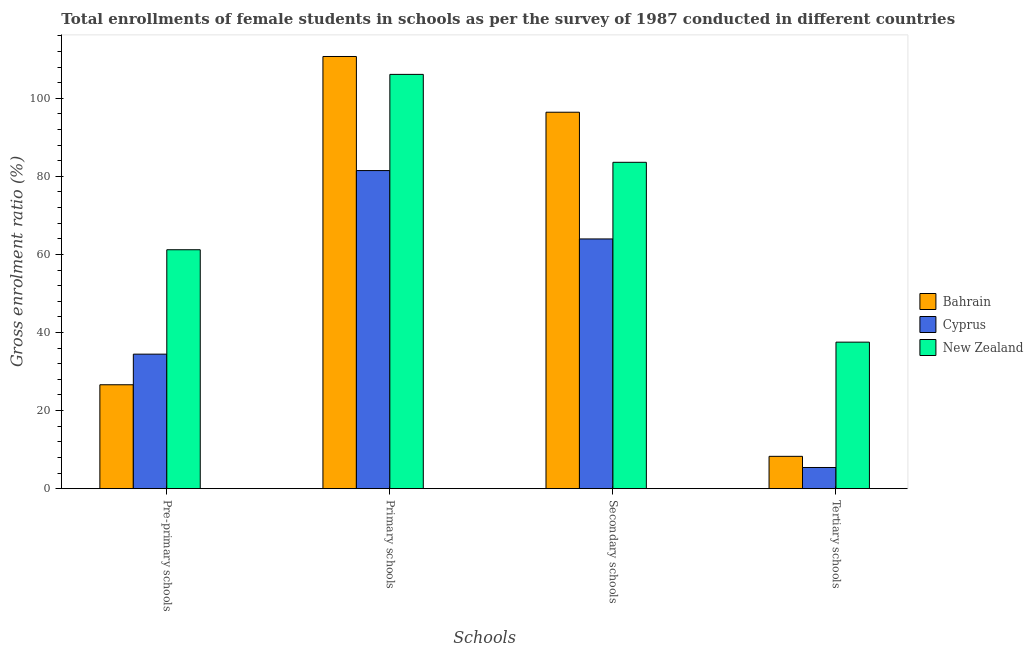How many different coloured bars are there?
Provide a succinct answer. 3. How many groups of bars are there?
Ensure brevity in your answer.  4. Are the number of bars on each tick of the X-axis equal?
Ensure brevity in your answer.  Yes. How many bars are there on the 4th tick from the left?
Your answer should be very brief. 3. How many bars are there on the 2nd tick from the right?
Offer a very short reply. 3. What is the label of the 1st group of bars from the left?
Provide a succinct answer. Pre-primary schools. What is the gross enrolment ratio(female) in primary schools in New Zealand?
Provide a succinct answer. 106.12. Across all countries, what is the maximum gross enrolment ratio(female) in pre-primary schools?
Ensure brevity in your answer.  61.2. Across all countries, what is the minimum gross enrolment ratio(female) in tertiary schools?
Keep it short and to the point. 5.43. In which country was the gross enrolment ratio(female) in pre-primary schools maximum?
Offer a very short reply. New Zealand. In which country was the gross enrolment ratio(female) in primary schools minimum?
Provide a short and direct response. Cyprus. What is the total gross enrolment ratio(female) in tertiary schools in the graph?
Offer a terse response. 51.24. What is the difference between the gross enrolment ratio(female) in tertiary schools in Bahrain and that in Cyprus?
Your answer should be very brief. 2.86. What is the difference between the gross enrolment ratio(female) in tertiary schools in New Zealand and the gross enrolment ratio(female) in primary schools in Bahrain?
Make the answer very short. -73.17. What is the average gross enrolment ratio(female) in pre-primary schools per country?
Ensure brevity in your answer.  40.76. What is the difference between the gross enrolment ratio(female) in secondary schools and gross enrolment ratio(female) in primary schools in Bahrain?
Your answer should be compact. -14.28. In how many countries, is the gross enrolment ratio(female) in primary schools greater than 84 %?
Offer a terse response. 2. What is the ratio of the gross enrolment ratio(female) in primary schools in New Zealand to that in Bahrain?
Offer a very short reply. 0.96. Is the gross enrolment ratio(female) in pre-primary schools in Cyprus less than that in New Zealand?
Provide a short and direct response. Yes. Is the difference between the gross enrolment ratio(female) in primary schools in Cyprus and Bahrain greater than the difference between the gross enrolment ratio(female) in tertiary schools in Cyprus and Bahrain?
Offer a very short reply. No. What is the difference between the highest and the second highest gross enrolment ratio(female) in primary schools?
Give a very brief answer. 4.58. What is the difference between the highest and the lowest gross enrolment ratio(female) in tertiary schools?
Your response must be concise. 32.1. In how many countries, is the gross enrolment ratio(female) in pre-primary schools greater than the average gross enrolment ratio(female) in pre-primary schools taken over all countries?
Your answer should be compact. 1. What does the 3rd bar from the left in Tertiary schools represents?
Keep it short and to the point. New Zealand. What does the 2nd bar from the right in Tertiary schools represents?
Give a very brief answer. Cyprus. Does the graph contain any zero values?
Ensure brevity in your answer.  No. Where does the legend appear in the graph?
Provide a succinct answer. Center right. What is the title of the graph?
Offer a terse response. Total enrollments of female students in schools as per the survey of 1987 conducted in different countries. Does "Sub-Saharan Africa (developing only)" appear as one of the legend labels in the graph?
Make the answer very short. No. What is the label or title of the X-axis?
Provide a succinct answer. Schools. What is the label or title of the Y-axis?
Offer a very short reply. Gross enrolment ratio (%). What is the Gross enrolment ratio (%) in Bahrain in Pre-primary schools?
Your answer should be compact. 26.62. What is the Gross enrolment ratio (%) of Cyprus in Pre-primary schools?
Your answer should be compact. 34.46. What is the Gross enrolment ratio (%) of New Zealand in Pre-primary schools?
Offer a terse response. 61.2. What is the Gross enrolment ratio (%) of Bahrain in Primary schools?
Your answer should be very brief. 110.7. What is the Gross enrolment ratio (%) of Cyprus in Primary schools?
Make the answer very short. 81.48. What is the Gross enrolment ratio (%) in New Zealand in Primary schools?
Provide a short and direct response. 106.12. What is the Gross enrolment ratio (%) in Bahrain in Secondary schools?
Offer a terse response. 96.43. What is the Gross enrolment ratio (%) in Cyprus in Secondary schools?
Provide a short and direct response. 63.97. What is the Gross enrolment ratio (%) in New Zealand in Secondary schools?
Provide a succinct answer. 83.6. What is the Gross enrolment ratio (%) in Bahrain in Tertiary schools?
Provide a succinct answer. 8.28. What is the Gross enrolment ratio (%) of Cyprus in Tertiary schools?
Your answer should be very brief. 5.43. What is the Gross enrolment ratio (%) in New Zealand in Tertiary schools?
Provide a succinct answer. 37.53. Across all Schools, what is the maximum Gross enrolment ratio (%) of Bahrain?
Ensure brevity in your answer.  110.7. Across all Schools, what is the maximum Gross enrolment ratio (%) of Cyprus?
Provide a short and direct response. 81.48. Across all Schools, what is the maximum Gross enrolment ratio (%) of New Zealand?
Your answer should be compact. 106.12. Across all Schools, what is the minimum Gross enrolment ratio (%) in Bahrain?
Keep it short and to the point. 8.28. Across all Schools, what is the minimum Gross enrolment ratio (%) in Cyprus?
Ensure brevity in your answer.  5.43. Across all Schools, what is the minimum Gross enrolment ratio (%) in New Zealand?
Give a very brief answer. 37.53. What is the total Gross enrolment ratio (%) of Bahrain in the graph?
Your answer should be very brief. 242.03. What is the total Gross enrolment ratio (%) of Cyprus in the graph?
Ensure brevity in your answer.  185.33. What is the total Gross enrolment ratio (%) of New Zealand in the graph?
Offer a very short reply. 288.45. What is the difference between the Gross enrolment ratio (%) of Bahrain in Pre-primary schools and that in Primary schools?
Your response must be concise. -84.09. What is the difference between the Gross enrolment ratio (%) of Cyprus in Pre-primary schools and that in Primary schools?
Offer a terse response. -47.02. What is the difference between the Gross enrolment ratio (%) in New Zealand in Pre-primary schools and that in Primary schools?
Ensure brevity in your answer.  -44.92. What is the difference between the Gross enrolment ratio (%) in Bahrain in Pre-primary schools and that in Secondary schools?
Offer a very short reply. -69.81. What is the difference between the Gross enrolment ratio (%) of Cyprus in Pre-primary schools and that in Secondary schools?
Your answer should be very brief. -29.51. What is the difference between the Gross enrolment ratio (%) in New Zealand in Pre-primary schools and that in Secondary schools?
Your response must be concise. -22.4. What is the difference between the Gross enrolment ratio (%) in Bahrain in Pre-primary schools and that in Tertiary schools?
Keep it short and to the point. 18.33. What is the difference between the Gross enrolment ratio (%) of Cyprus in Pre-primary schools and that in Tertiary schools?
Provide a short and direct response. 29.03. What is the difference between the Gross enrolment ratio (%) in New Zealand in Pre-primary schools and that in Tertiary schools?
Your answer should be very brief. 23.67. What is the difference between the Gross enrolment ratio (%) of Bahrain in Primary schools and that in Secondary schools?
Give a very brief answer. 14.28. What is the difference between the Gross enrolment ratio (%) of Cyprus in Primary schools and that in Secondary schools?
Keep it short and to the point. 17.51. What is the difference between the Gross enrolment ratio (%) in New Zealand in Primary schools and that in Secondary schools?
Your response must be concise. 22.52. What is the difference between the Gross enrolment ratio (%) of Bahrain in Primary schools and that in Tertiary schools?
Make the answer very short. 102.42. What is the difference between the Gross enrolment ratio (%) of Cyprus in Primary schools and that in Tertiary schools?
Offer a terse response. 76.05. What is the difference between the Gross enrolment ratio (%) of New Zealand in Primary schools and that in Tertiary schools?
Ensure brevity in your answer.  68.59. What is the difference between the Gross enrolment ratio (%) of Bahrain in Secondary schools and that in Tertiary schools?
Offer a terse response. 88.14. What is the difference between the Gross enrolment ratio (%) in Cyprus in Secondary schools and that in Tertiary schools?
Provide a succinct answer. 58.54. What is the difference between the Gross enrolment ratio (%) in New Zealand in Secondary schools and that in Tertiary schools?
Offer a terse response. 46.07. What is the difference between the Gross enrolment ratio (%) of Bahrain in Pre-primary schools and the Gross enrolment ratio (%) of Cyprus in Primary schools?
Your answer should be very brief. -54.86. What is the difference between the Gross enrolment ratio (%) in Bahrain in Pre-primary schools and the Gross enrolment ratio (%) in New Zealand in Primary schools?
Provide a succinct answer. -79.5. What is the difference between the Gross enrolment ratio (%) of Cyprus in Pre-primary schools and the Gross enrolment ratio (%) of New Zealand in Primary schools?
Your answer should be compact. -71.66. What is the difference between the Gross enrolment ratio (%) of Bahrain in Pre-primary schools and the Gross enrolment ratio (%) of Cyprus in Secondary schools?
Offer a very short reply. -37.35. What is the difference between the Gross enrolment ratio (%) in Bahrain in Pre-primary schools and the Gross enrolment ratio (%) in New Zealand in Secondary schools?
Your response must be concise. -56.98. What is the difference between the Gross enrolment ratio (%) in Cyprus in Pre-primary schools and the Gross enrolment ratio (%) in New Zealand in Secondary schools?
Provide a short and direct response. -49.14. What is the difference between the Gross enrolment ratio (%) of Bahrain in Pre-primary schools and the Gross enrolment ratio (%) of Cyprus in Tertiary schools?
Offer a terse response. 21.19. What is the difference between the Gross enrolment ratio (%) of Bahrain in Pre-primary schools and the Gross enrolment ratio (%) of New Zealand in Tertiary schools?
Provide a succinct answer. -10.92. What is the difference between the Gross enrolment ratio (%) of Cyprus in Pre-primary schools and the Gross enrolment ratio (%) of New Zealand in Tertiary schools?
Make the answer very short. -3.07. What is the difference between the Gross enrolment ratio (%) in Bahrain in Primary schools and the Gross enrolment ratio (%) in Cyprus in Secondary schools?
Your answer should be very brief. 46.74. What is the difference between the Gross enrolment ratio (%) of Bahrain in Primary schools and the Gross enrolment ratio (%) of New Zealand in Secondary schools?
Provide a succinct answer. 27.11. What is the difference between the Gross enrolment ratio (%) in Cyprus in Primary schools and the Gross enrolment ratio (%) in New Zealand in Secondary schools?
Make the answer very short. -2.12. What is the difference between the Gross enrolment ratio (%) of Bahrain in Primary schools and the Gross enrolment ratio (%) of Cyprus in Tertiary schools?
Make the answer very short. 105.28. What is the difference between the Gross enrolment ratio (%) of Bahrain in Primary schools and the Gross enrolment ratio (%) of New Zealand in Tertiary schools?
Keep it short and to the point. 73.17. What is the difference between the Gross enrolment ratio (%) of Cyprus in Primary schools and the Gross enrolment ratio (%) of New Zealand in Tertiary schools?
Your answer should be compact. 43.95. What is the difference between the Gross enrolment ratio (%) of Bahrain in Secondary schools and the Gross enrolment ratio (%) of Cyprus in Tertiary schools?
Give a very brief answer. 91. What is the difference between the Gross enrolment ratio (%) in Bahrain in Secondary schools and the Gross enrolment ratio (%) in New Zealand in Tertiary schools?
Provide a short and direct response. 58.89. What is the difference between the Gross enrolment ratio (%) of Cyprus in Secondary schools and the Gross enrolment ratio (%) of New Zealand in Tertiary schools?
Give a very brief answer. 26.44. What is the average Gross enrolment ratio (%) of Bahrain per Schools?
Offer a very short reply. 60.51. What is the average Gross enrolment ratio (%) of Cyprus per Schools?
Make the answer very short. 46.33. What is the average Gross enrolment ratio (%) in New Zealand per Schools?
Make the answer very short. 72.11. What is the difference between the Gross enrolment ratio (%) of Bahrain and Gross enrolment ratio (%) of Cyprus in Pre-primary schools?
Ensure brevity in your answer.  -7.84. What is the difference between the Gross enrolment ratio (%) of Bahrain and Gross enrolment ratio (%) of New Zealand in Pre-primary schools?
Ensure brevity in your answer.  -34.59. What is the difference between the Gross enrolment ratio (%) of Cyprus and Gross enrolment ratio (%) of New Zealand in Pre-primary schools?
Keep it short and to the point. -26.74. What is the difference between the Gross enrolment ratio (%) in Bahrain and Gross enrolment ratio (%) in Cyprus in Primary schools?
Keep it short and to the point. 29.22. What is the difference between the Gross enrolment ratio (%) in Bahrain and Gross enrolment ratio (%) in New Zealand in Primary schools?
Your response must be concise. 4.58. What is the difference between the Gross enrolment ratio (%) in Cyprus and Gross enrolment ratio (%) in New Zealand in Primary schools?
Your answer should be very brief. -24.64. What is the difference between the Gross enrolment ratio (%) of Bahrain and Gross enrolment ratio (%) of Cyprus in Secondary schools?
Offer a very short reply. 32.46. What is the difference between the Gross enrolment ratio (%) in Bahrain and Gross enrolment ratio (%) in New Zealand in Secondary schools?
Your answer should be very brief. 12.83. What is the difference between the Gross enrolment ratio (%) in Cyprus and Gross enrolment ratio (%) in New Zealand in Secondary schools?
Ensure brevity in your answer.  -19.63. What is the difference between the Gross enrolment ratio (%) of Bahrain and Gross enrolment ratio (%) of Cyprus in Tertiary schools?
Make the answer very short. 2.86. What is the difference between the Gross enrolment ratio (%) in Bahrain and Gross enrolment ratio (%) in New Zealand in Tertiary schools?
Provide a succinct answer. -29.25. What is the difference between the Gross enrolment ratio (%) in Cyprus and Gross enrolment ratio (%) in New Zealand in Tertiary schools?
Give a very brief answer. -32.1. What is the ratio of the Gross enrolment ratio (%) of Bahrain in Pre-primary schools to that in Primary schools?
Ensure brevity in your answer.  0.24. What is the ratio of the Gross enrolment ratio (%) in Cyprus in Pre-primary schools to that in Primary schools?
Offer a very short reply. 0.42. What is the ratio of the Gross enrolment ratio (%) in New Zealand in Pre-primary schools to that in Primary schools?
Your answer should be compact. 0.58. What is the ratio of the Gross enrolment ratio (%) in Bahrain in Pre-primary schools to that in Secondary schools?
Give a very brief answer. 0.28. What is the ratio of the Gross enrolment ratio (%) in Cyprus in Pre-primary schools to that in Secondary schools?
Provide a succinct answer. 0.54. What is the ratio of the Gross enrolment ratio (%) in New Zealand in Pre-primary schools to that in Secondary schools?
Keep it short and to the point. 0.73. What is the ratio of the Gross enrolment ratio (%) in Bahrain in Pre-primary schools to that in Tertiary schools?
Your answer should be compact. 3.21. What is the ratio of the Gross enrolment ratio (%) of Cyprus in Pre-primary schools to that in Tertiary schools?
Your answer should be compact. 6.35. What is the ratio of the Gross enrolment ratio (%) in New Zealand in Pre-primary schools to that in Tertiary schools?
Provide a succinct answer. 1.63. What is the ratio of the Gross enrolment ratio (%) of Bahrain in Primary schools to that in Secondary schools?
Your answer should be very brief. 1.15. What is the ratio of the Gross enrolment ratio (%) of Cyprus in Primary schools to that in Secondary schools?
Provide a short and direct response. 1.27. What is the ratio of the Gross enrolment ratio (%) of New Zealand in Primary schools to that in Secondary schools?
Your answer should be very brief. 1.27. What is the ratio of the Gross enrolment ratio (%) of Bahrain in Primary schools to that in Tertiary schools?
Your answer should be compact. 13.36. What is the ratio of the Gross enrolment ratio (%) in Cyprus in Primary schools to that in Tertiary schools?
Offer a terse response. 15.01. What is the ratio of the Gross enrolment ratio (%) of New Zealand in Primary schools to that in Tertiary schools?
Provide a short and direct response. 2.83. What is the ratio of the Gross enrolment ratio (%) in Bahrain in Secondary schools to that in Tertiary schools?
Provide a short and direct response. 11.64. What is the ratio of the Gross enrolment ratio (%) in Cyprus in Secondary schools to that in Tertiary schools?
Keep it short and to the point. 11.79. What is the ratio of the Gross enrolment ratio (%) in New Zealand in Secondary schools to that in Tertiary schools?
Your answer should be very brief. 2.23. What is the difference between the highest and the second highest Gross enrolment ratio (%) in Bahrain?
Your response must be concise. 14.28. What is the difference between the highest and the second highest Gross enrolment ratio (%) in Cyprus?
Your response must be concise. 17.51. What is the difference between the highest and the second highest Gross enrolment ratio (%) of New Zealand?
Give a very brief answer. 22.52. What is the difference between the highest and the lowest Gross enrolment ratio (%) in Bahrain?
Provide a short and direct response. 102.42. What is the difference between the highest and the lowest Gross enrolment ratio (%) in Cyprus?
Give a very brief answer. 76.05. What is the difference between the highest and the lowest Gross enrolment ratio (%) of New Zealand?
Keep it short and to the point. 68.59. 